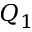<formula> <loc_0><loc_0><loc_500><loc_500>Q _ { 1 }</formula> 